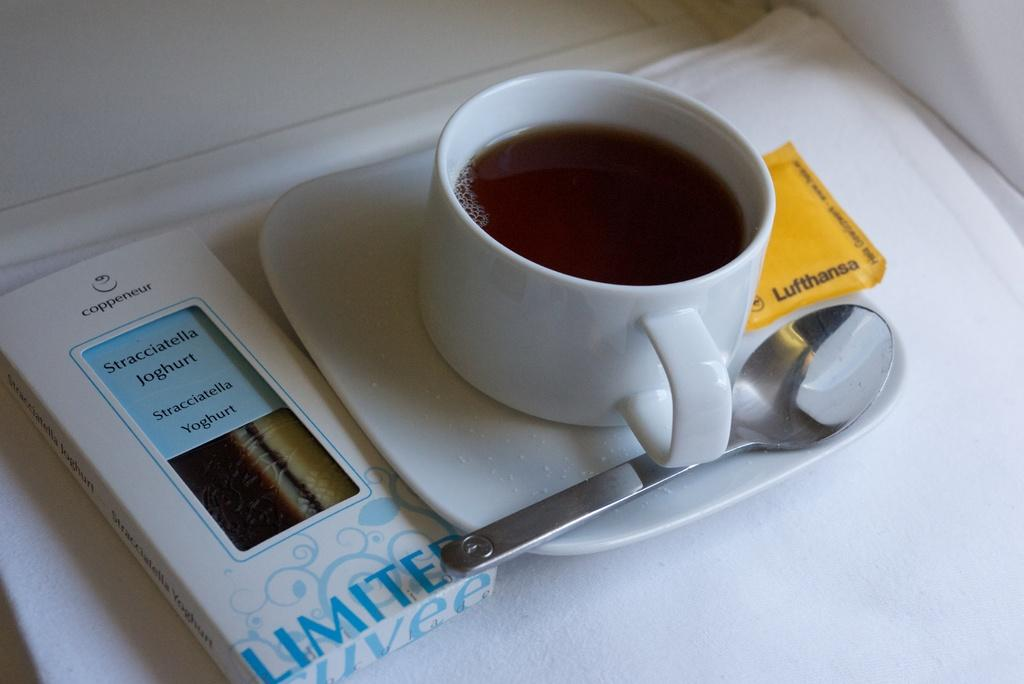What is in the cup that is visible in the image? There is a cup of tea in the image. What is the cup of tea resting on? The cup of tea is on a saucer. What utensil is present in the saucer? There is a spoon in the saucer. What object can be seen on the left side of the image? There is a box on the left side of the image. What type of fuel is being used to power the cup of tea in the image? There is no fuel present in the image, as the cup of tea is not a machine or device that requires fuel to function. 